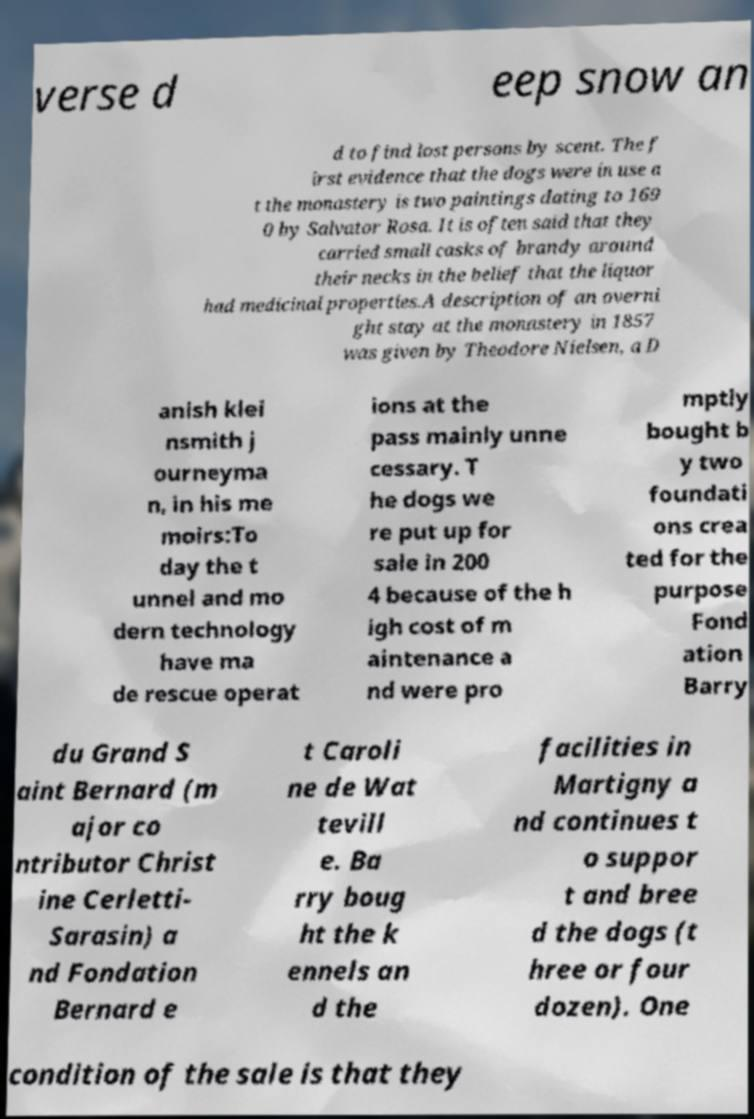Can you accurately transcribe the text from the provided image for me? verse d eep snow an d to find lost persons by scent. The f irst evidence that the dogs were in use a t the monastery is two paintings dating to 169 0 by Salvator Rosa. It is often said that they carried small casks of brandy around their necks in the belief that the liquor had medicinal properties.A description of an overni ght stay at the monastery in 1857 was given by Theodore Nielsen, a D anish klei nsmith j ourneyma n, in his me moirs:To day the t unnel and mo dern technology have ma de rescue operat ions at the pass mainly unne cessary. T he dogs we re put up for sale in 200 4 because of the h igh cost of m aintenance a nd were pro mptly bought b y two foundati ons crea ted for the purpose Fond ation Barry du Grand S aint Bernard (m ajor co ntributor Christ ine Cerletti- Sarasin) a nd Fondation Bernard e t Caroli ne de Wat tevill e. Ba rry boug ht the k ennels an d the facilities in Martigny a nd continues t o suppor t and bree d the dogs (t hree or four dozen). One condition of the sale is that they 